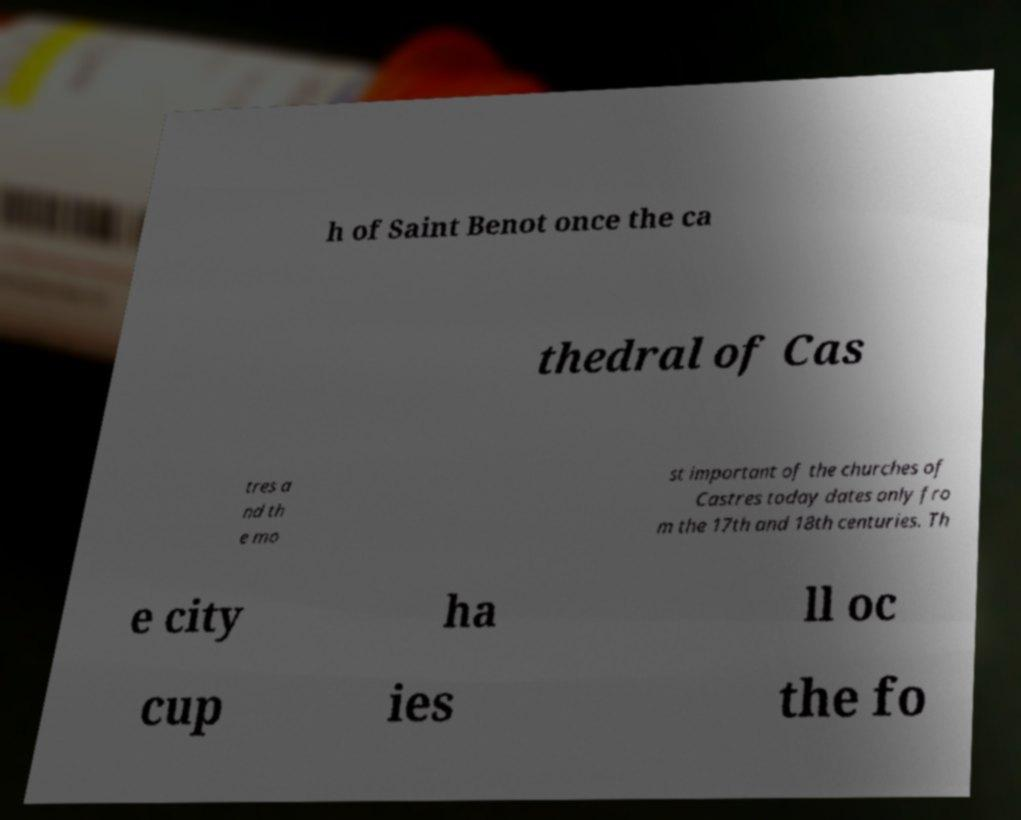Please read and relay the text visible in this image. What does it say? h of Saint Benot once the ca thedral of Cas tres a nd th e mo st important of the churches of Castres today dates only fro m the 17th and 18th centuries. Th e city ha ll oc cup ies the fo 